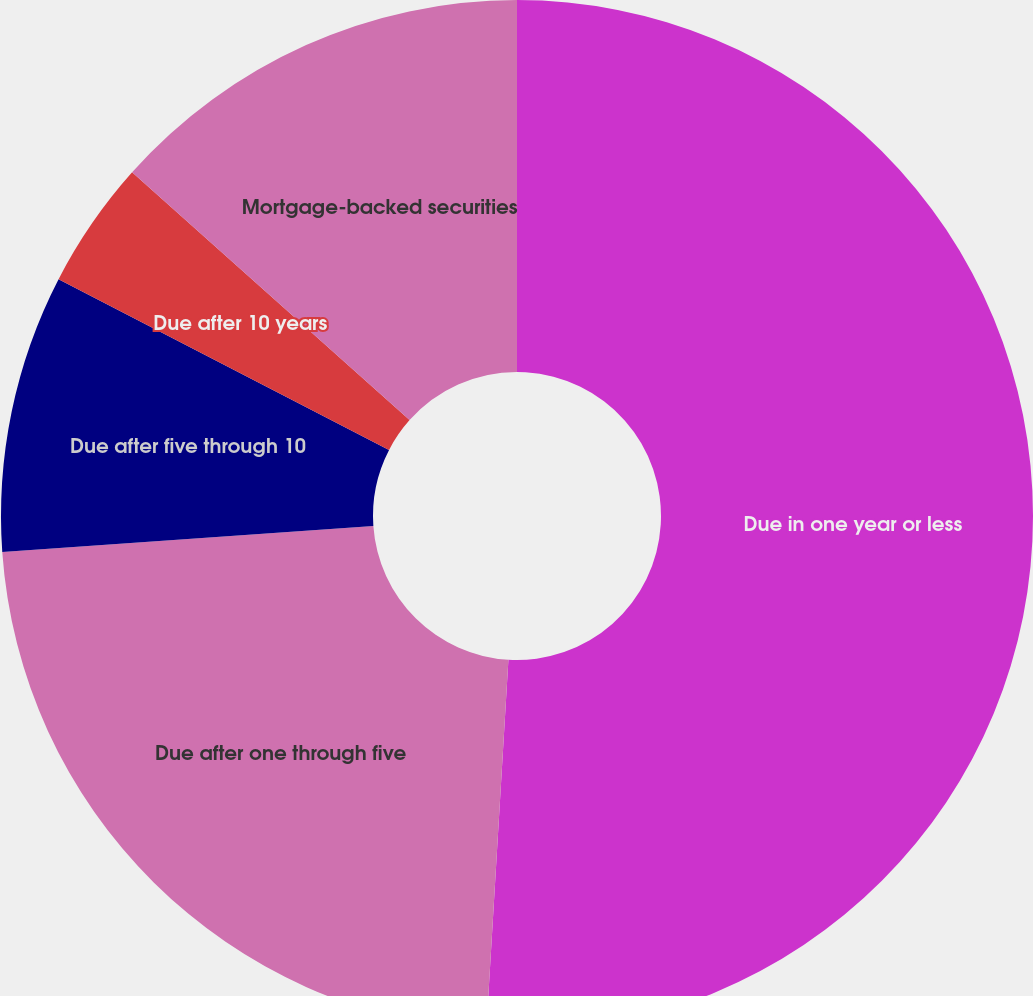Convert chart to OTSL. <chart><loc_0><loc_0><loc_500><loc_500><pie_chart><fcel>Due in one year or less<fcel>Due after one through five<fcel>Due after five through 10<fcel>Due after 10 years<fcel>Mortgage-backed securities<nl><fcel>50.95%<fcel>22.94%<fcel>8.7%<fcel>4.01%<fcel>13.4%<nl></chart> 